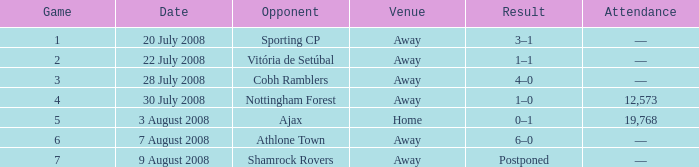What is the result of the game with a game number greater than 6 and an away venue? Postponed. 